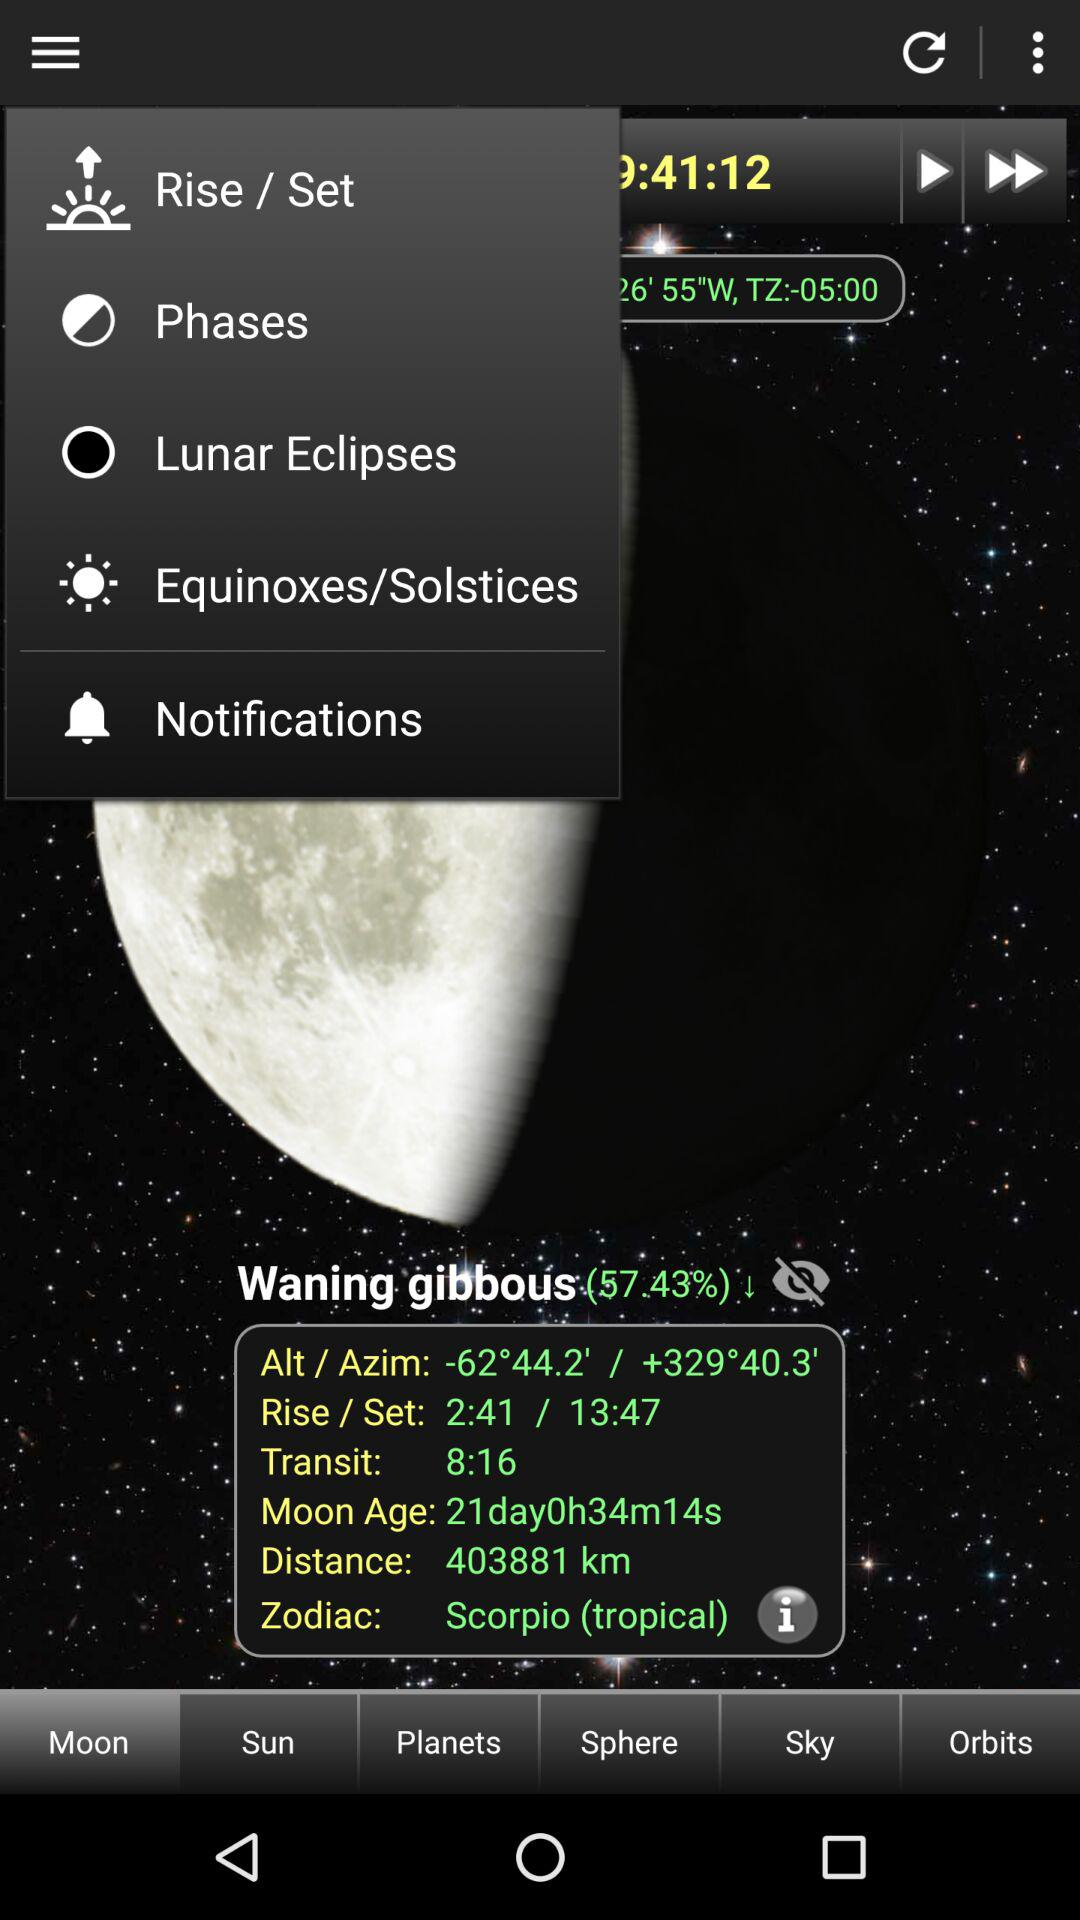What is the moon's zodiac sign?
Answer the question using a single word or phrase. Scorpio (tropical) 